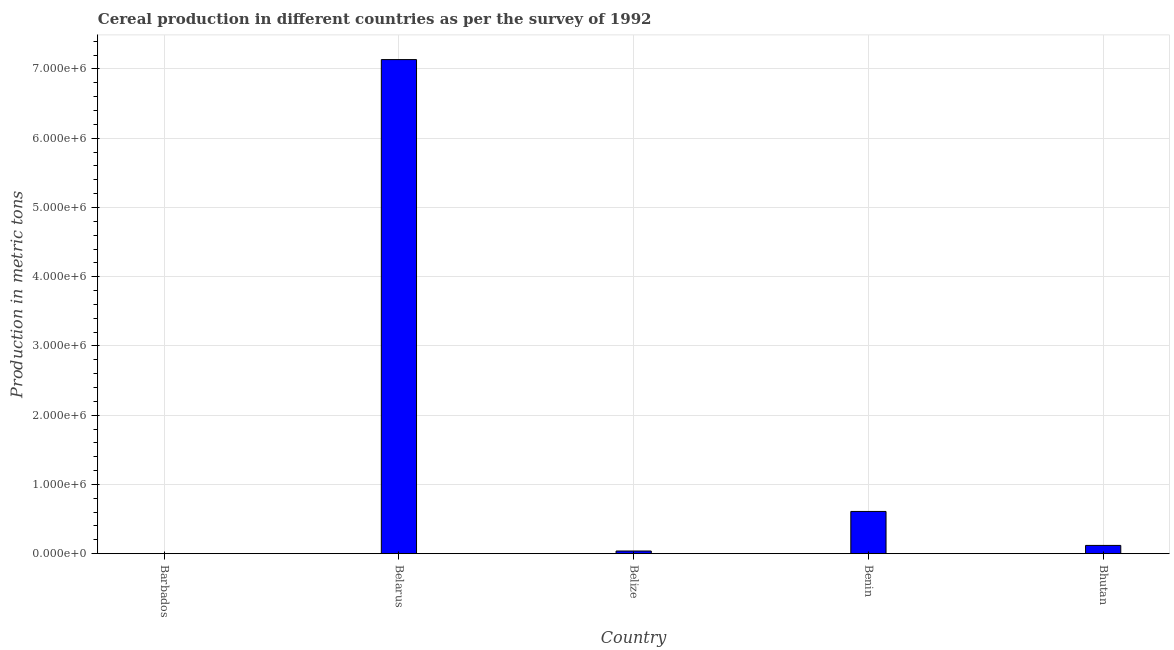Does the graph contain grids?
Your response must be concise. Yes. What is the title of the graph?
Provide a short and direct response. Cereal production in different countries as per the survey of 1992. What is the label or title of the Y-axis?
Offer a very short reply. Production in metric tons. What is the cereal production in Benin?
Provide a short and direct response. 6.09e+05. Across all countries, what is the maximum cereal production?
Make the answer very short. 7.14e+06. Across all countries, what is the minimum cereal production?
Provide a succinct answer. 1800. In which country was the cereal production maximum?
Give a very brief answer. Belarus. In which country was the cereal production minimum?
Make the answer very short. Barbados. What is the sum of the cereal production?
Keep it short and to the point. 7.90e+06. What is the difference between the cereal production in Barbados and Belarus?
Make the answer very short. -7.13e+06. What is the average cereal production per country?
Your answer should be compact. 1.58e+06. What is the median cereal production?
Offer a terse response. 1.19e+05. Is the cereal production in Belize less than that in Bhutan?
Provide a short and direct response. Yes. What is the difference between the highest and the second highest cereal production?
Your response must be concise. 6.53e+06. What is the difference between the highest and the lowest cereal production?
Provide a succinct answer. 7.13e+06. Are all the bars in the graph horizontal?
Give a very brief answer. No. How many countries are there in the graph?
Your answer should be very brief. 5. What is the difference between two consecutive major ticks on the Y-axis?
Offer a terse response. 1.00e+06. What is the Production in metric tons in Barbados?
Offer a terse response. 1800. What is the Production in metric tons in Belarus?
Provide a short and direct response. 7.14e+06. What is the Production in metric tons of Belize?
Keep it short and to the point. 3.81e+04. What is the Production in metric tons in Benin?
Your answer should be very brief. 6.09e+05. What is the Production in metric tons in Bhutan?
Offer a terse response. 1.19e+05. What is the difference between the Production in metric tons in Barbados and Belarus?
Offer a very short reply. -7.13e+06. What is the difference between the Production in metric tons in Barbados and Belize?
Provide a succinct answer. -3.63e+04. What is the difference between the Production in metric tons in Barbados and Benin?
Offer a terse response. -6.08e+05. What is the difference between the Production in metric tons in Barbados and Bhutan?
Your response must be concise. -1.17e+05. What is the difference between the Production in metric tons in Belarus and Belize?
Ensure brevity in your answer.  7.10e+06. What is the difference between the Production in metric tons in Belarus and Benin?
Your response must be concise. 6.53e+06. What is the difference between the Production in metric tons in Belarus and Bhutan?
Give a very brief answer. 7.02e+06. What is the difference between the Production in metric tons in Belize and Benin?
Provide a succinct answer. -5.71e+05. What is the difference between the Production in metric tons in Belize and Bhutan?
Your answer should be very brief. -8.07e+04. What is the difference between the Production in metric tons in Benin and Bhutan?
Provide a short and direct response. 4.91e+05. What is the ratio of the Production in metric tons in Barbados to that in Belize?
Ensure brevity in your answer.  0.05. What is the ratio of the Production in metric tons in Barbados to that in Benin?
Provide a succinct answer. 0. What is the ratio of the Production in metric tons in Barbados to that in Bhutan?
Make the answer very short. 0.01. What is the ratio of the Production in metric tons in Belarus to that in Belize?
Offer a very short reply. 187.32. What is the ratio of the Production in metric tons in Belarus to that in Benin?
Your answer should be compact. 11.71. What is the ratio of the Production in metric tons in Belarus to that in Bhutan?
Provide a short and direct response. 60.07. What is the ratio of the Production in metric tons in Belize to that in Benin?
Make the answer very short. 0.06. What is the ratio of the Production in metric tons in Belize to that in Bhutan?
Your answer should be compact. 0.32. What is the ratio of the Production in metric tons in Benin to that in Bhutan?
Provide a short and direct response. 5.13. 